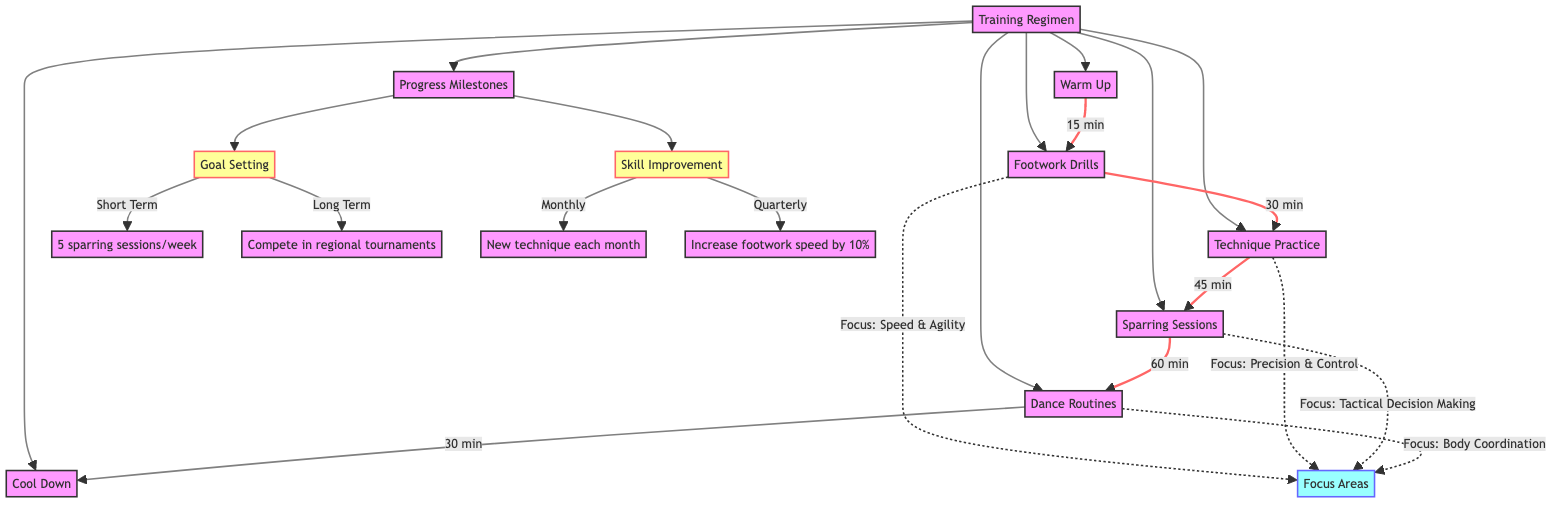What duration is allocated for Warm Up? The diagram shows that the duration of Warm Up is directly stated as "15 minutes."
Answer: 15 minutes What is the focus area of Technique Practice? Referring to the Focus Area connected to Technique Practice in the diagram, it is specified as "Precision and control."
Answer: Precision and control How many hours are dedicated to the entire training regimen? The durations for each training activity can be summed up: 15 minutes (Warm Up) + 30 minutes (Footwork Drills) + 45 minutes (Technique Practice) + 60 minutes (Sparring Sessions) + 30 minutes (Dance Routines) + 15 minutes (Cool Down) equals a total of 195 minutes, which is 3 hours and 15 minutes.
Answer: 3 hours and 15 minutes What are the short-term goals in Progress Milestones? The diagram indicates that under Goal Setting, the short-term goal is specifically labeled as "Complete 5 sparring sessions per week."
Answer: Complete 5 sparring sessions per week Which activity comes after Dance Routines in the training regimen? The diagram illustrates that the sequence flows from Dance Routines to Cool Down, meaning Cool Down is the next activity following Dance Routines.
Answer: Cool Down What is the monthly skill improvement goal stated in the Progress Milestones? Looking at Skill Improvement, the diagram specifies the monthly target as "Achieve a new technique each month," making this the answer.
Answer: Achieve a new technique each month Which focus area is associated with Sparring Sessions? The diagram states that Sparring Sessions have a focus on "Tactical decision making," linking this area of focus to the activity directly.
Answer: Tactical decision making How many focus areas are represented in the diagram? The activities have the following focus areas: Speed & Agility, Precision & Control, Tactical Decision Making, and Body Coordination. This gives a total of 4 distinct focus areas shown in the diagram.
Answer: 4 